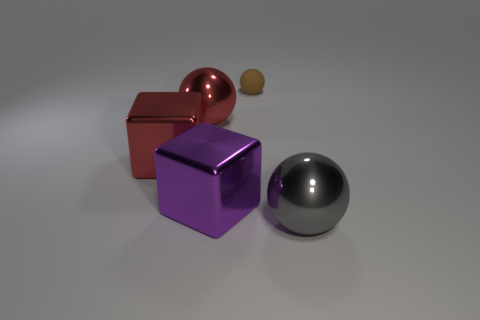How many large things are red metallic objects or rubber things? 2 